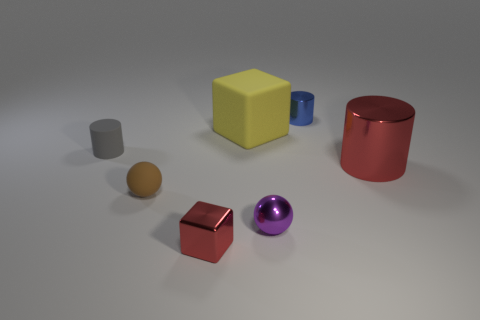Are there fewer large yellow rubber blocks that are on the right side of the tiny blue metallic thing than purple matte things?
Make the answer very short. No. Do the purple thing and the brown rubber object have the same shape?
Provide a short and direct response. Yes. There is a blue cylinder that is made of the same material as the purple thing; what is its size?
Your answer should be very brief. Small. Is the number of large brown matte spheres less than the number of yellow objects?
Provide a short and direct response. Yes. What number of small objects are cubes or red cylinders?
Offer a terse response. 1. What number of metallic objects are both in front of the tiny rubber cylinder and to the right of the big rubber cube?
Your answer should be very brief. 2. Are there more small green metal objects than red things?
Give a very brief answer. No. What number of other objects are there of the same shape as the small purple thing?
Your answer should be compact. 1. Is the color of the big metallic object the same as the tiny block?
Provide a short and direct response. Yes. What material is the cylinder that is in front of the blue metallic object and on the right side of the brown ball?
Provide a short and direct response. Metal. 